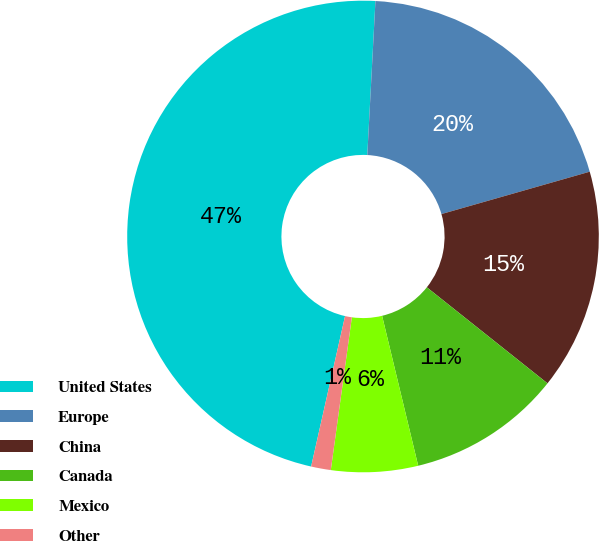<chart> <loc_0><loc_0><loc_500><loc_500><pie_chart><fcel>United States<fcel>Europe<fcel>China<fcel>Canada<fcel>Mexico<fcel>Other<nl><fcel>47.31%<fcel>19.73%<fcel>15.13%<fcel>10.54%<fcel>5.94%<fcel>1.35%<nl></chart> 